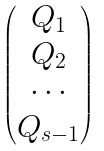Convert formula to latex. <formula><loc_0><loc_0><loc_500><loc_500>\begin{pmatrix} Q _ { 1 } \\ Q _ { 2 } \\ \cdots \\ Q _ { s - 1 } \\ \end{pmatrix}</formula> 